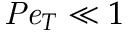<formula> <loc_0><loc_0><loc_500><loc_500>P e _ { T } \ll 1</formula> 